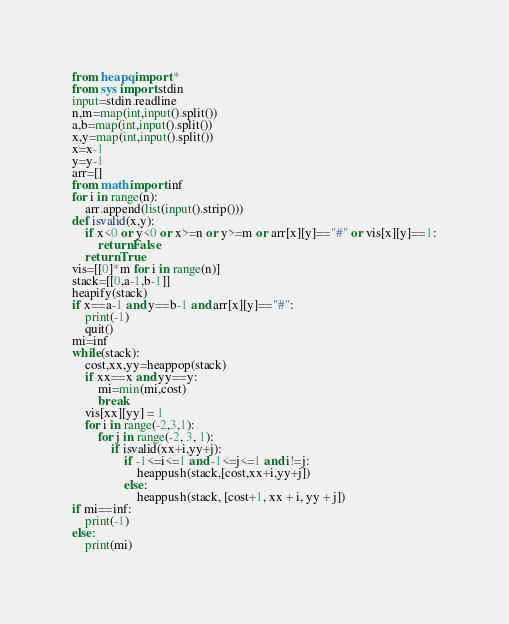Convert code to text. <code><loc_0><loc_0><loc_500><loc_500><_Python_>from heapq import *
from sys import stdin
input=stdin.readline
n,m=map(int,input().split())
a,b=map(int,input().split())
x,y=map(int,input().split())
x=x-1
y=y-1
arr=[]
from math import inf
for i in range(n):
    arr.append(list(input().strip()))
def isvalid(x,y):
    if x<0 or y<0 or x>=n or y>=m or arr[x][y]=="#" or vis[x][y]==1:
        return False
    return True
vis=[[0]*m for i in range(n)]
stack=[[0,a-1,b-1]]
heapify(stack)
if x==a-1 and y==b-1 and arr[x][y]=="#":
    print(-1)
    quit()
mi=inf
while(stack):
    cost,xx,yy=heappop(stack)
    if xx==x and yy==y:
        mi=min(mi,cost)
        break
    vis[xx][yy] = 1
    for i in range(-2,3,1):
        for j in range(-2, 3, 1):
            if isvalid(xx+i,yy+j):
                if -1<=i<=1 and -1<=j<=1 and i!=j:
                    heappush(stack,[cost,xx+i,yy+j])
                else:
                    heappush(stack, [cost+1, xx + i, yy + j])
if mi==inf:
    print(-1)
else:
    print(mi)

</code> 